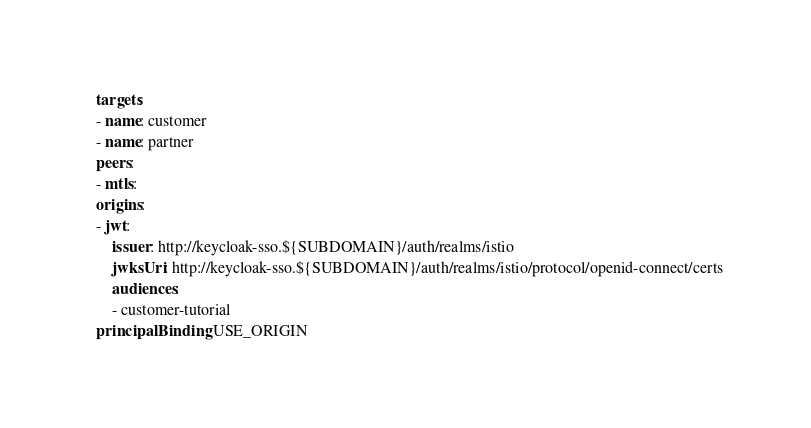Convert code to text. <code><loc_0><loc_0><loc_500><loc_500><_YAML_>  targets:
  - name: customer
  - name: partner
  peers:
  - mtls:
  origins:
  - jwt:
      issuer: http://keycloak-sso.${SUBDOMAIN}/auth/realms/istio
      jwksUri: http://keycloak-sso.${SUBDOMAIN}/auth/realms/istio/protocol/openid-connect/certs
      audiences:
      - customer-tutorial  
  principalBinding: USE_ORIGIN
</code> 